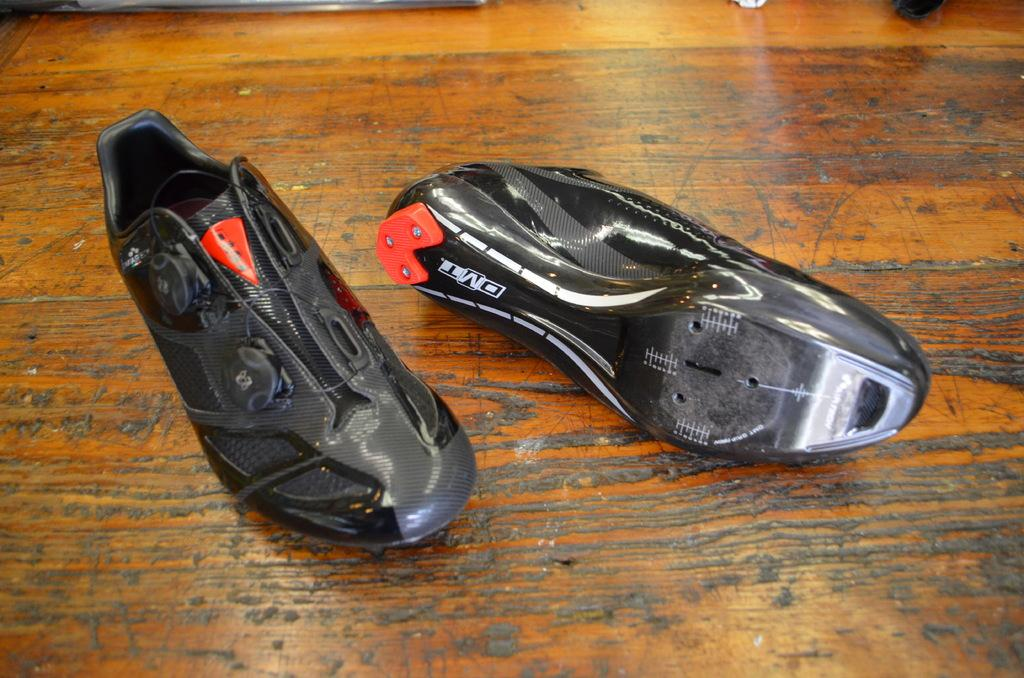What type of footwear is visible in the image? There are two black color shoes in the image. What is the surface on which the shoes are placed? The shoes are on a wooden surface. Reasoning: Leting: Let's think step by step in order to produce the conversation. We start by identifying the main subject in the image, which is the pair of black shoes. Then, we expand the conversation to include the surface on which the shoes are placed, which is a wooden surface. Each question is designed to elicit a specific detail about the image that is known from the provided facts. Absurd Question/Answer: What type of sheet is covering the shoes in the image? There is no sheet covering the shoes in the image; they are placed directly on the wooden surface. How does the eye react to the shoes in the image? There is no eye present in the image, so it is not possible to determine how an eye might react to the shoes. 